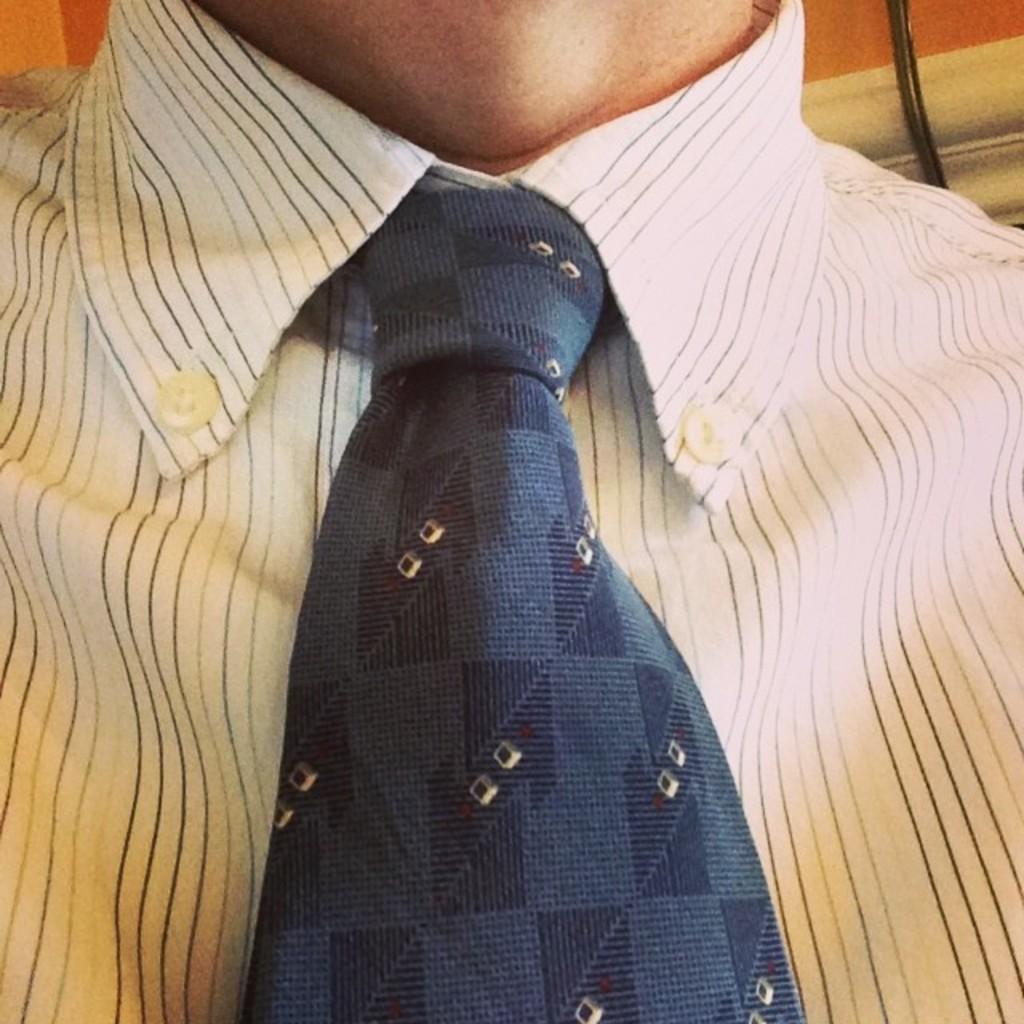Could you give a brief overview of what you see in this image? In this image, we can see a human wearing a shirt and tie. Here we can see buttons. Right side of the image, we can see a wire. 